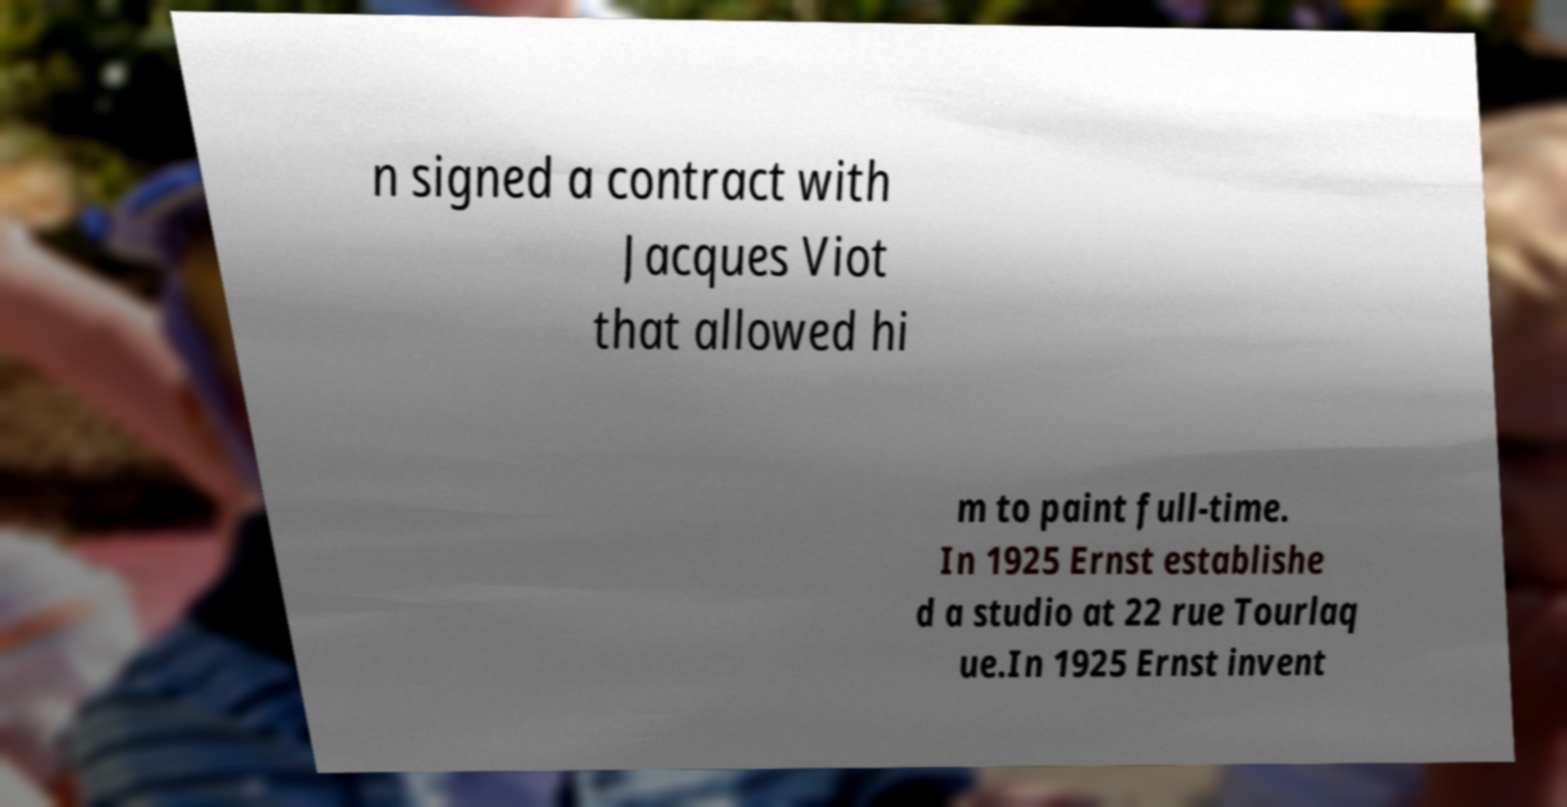I need the written content from this picture converted into text. Can you do that? n signed a contract with Jacques Viot that allowed hi m to paint full-time. In 1925 Ernst establishe d a studio at 22 rue Tourlaq ue.In 1925 Ernst invent 